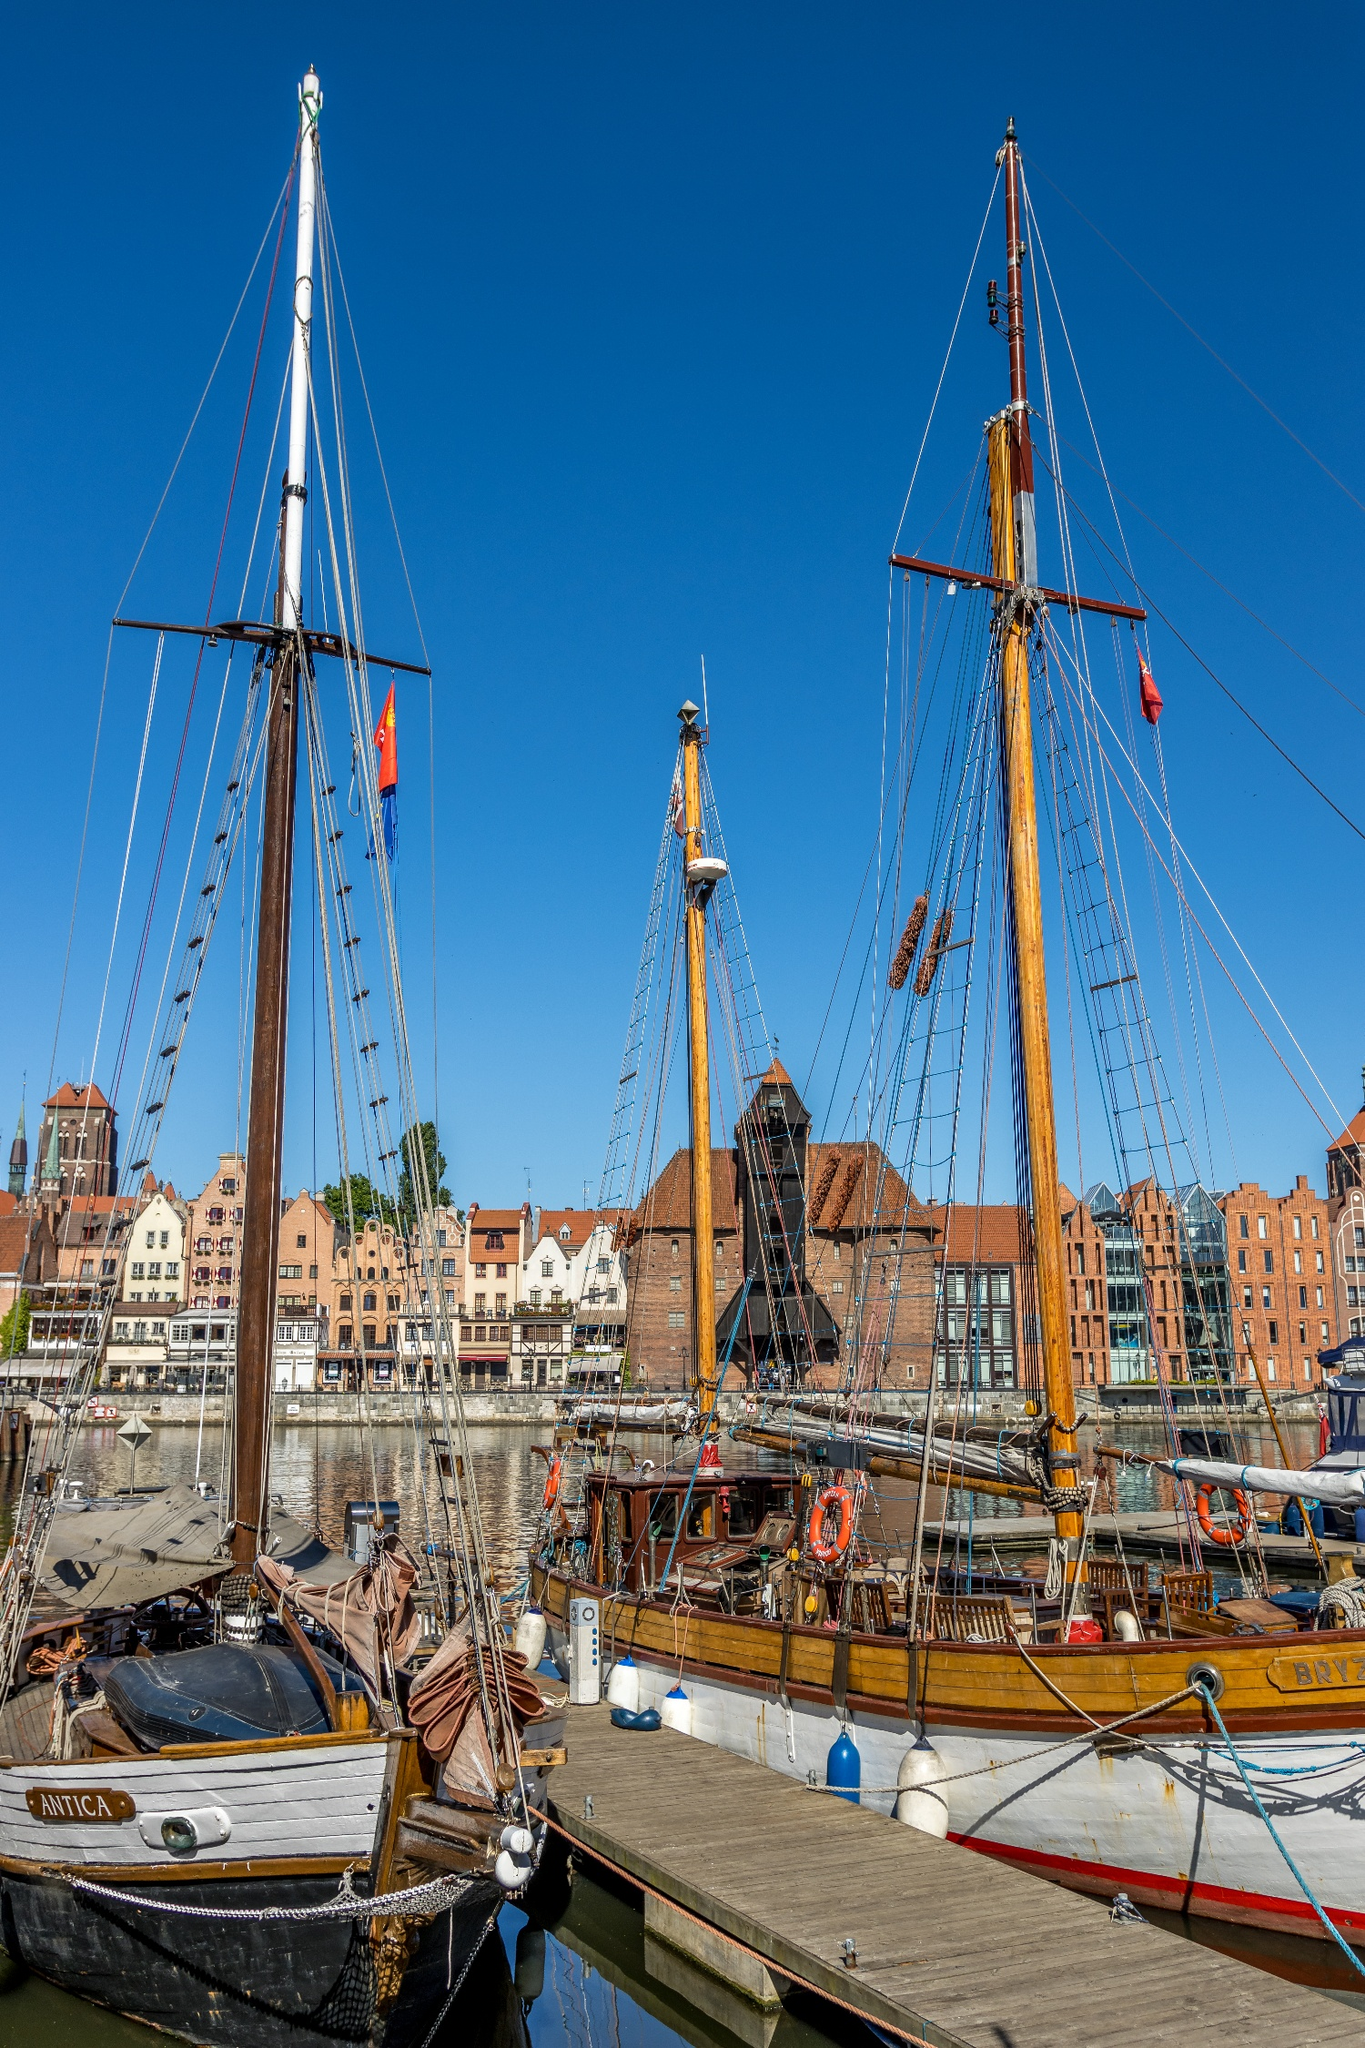Write a detailed description of the given image. This image captures the historic harbor of Gdansk, Poland, viewed from the perspective of the water. The harbor is bustling with old wooden sailing ships, their tall masts reaching for the clear blue sky, and colorful flags fluttering in the breeze. The cityscape in the background is a charming display of traditional brick and timber structures, their red roofs contrasting beautifully with the white walls. The calm water reflects the vibrant scene, adding to the overall tranquility of the image. The image code "sa_16263" suggests that this is a well-known landmark in Gdansk. The combination of the historic ships and the traditional architecture provides a glimpse into the rich history and culture of this Polish city. 